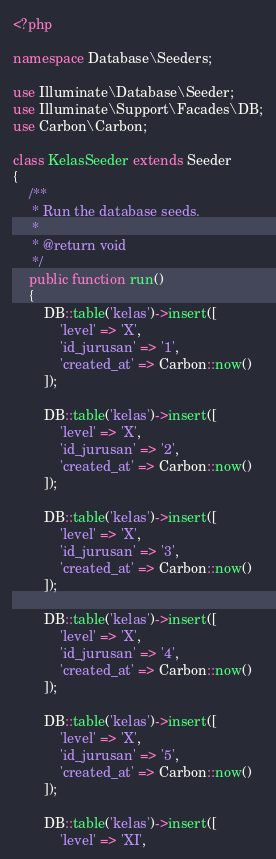Convert code to text. <code><loc_0><loc_0><loc_500><loc_500><_PHP_><?php

namespace Database\Seeders;

use Illuminate\Database\Seeder;
use Illuminate\Support\Facades\DB;
use Carbon\Carbon;

class KelasSeeder extends Seeder
{
    /**
     * Run the database seeds.
     *
     * @return void
     */
    public function run()
    {
        DB::table('kelas')->insert([
            'level' => 'X',
            'id_jurusan' => '1',
            'created_at' => Carbon::now()
        ]);

        DB::table('kelas')->insert([
            'level' => 'X',
            'id_jurusan' => '2',
            'created_at' => Carbon::now()
        ]);

        DB::table('kelas')->insert([
            'level' => 'X',
            'id_jurusan' => '3',
            'created_at' => Carbon::now()
        ]);

        DB::table('kelas')->insert([
            'level' => 'X',
            'id_jurusan' => '4',
            'created_at' => Carbon::now()
        ]);

        DB::table('kelas')->insert([
            'level' => 'X',
            'id_jurusan' => '5',
            'created_at' => Carbon::now()
        ]);

        DB::table('kelas')->insert([
            'level' => 'XI',</code> 